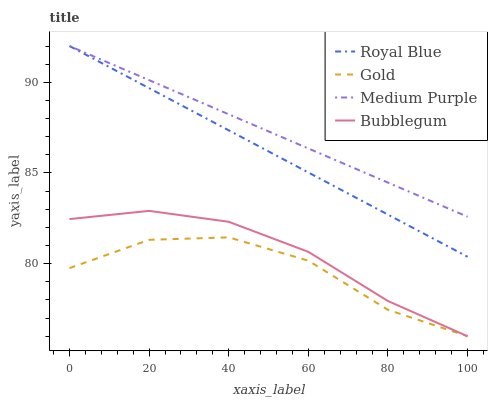Does Gold have the minimum area under the curve?
Answer yes or no. Yes. Does Medium Purple have the maximum area under the curve?
Answer yes or no. Yes. Does Royal Blue have the minimum area under the curve?
Answer yes or no. No. Does Royal Blue have the maximum area under the curve?
Answer yes or no. No. Is Royal Blue the smoothest?
Answer yes or no. Yes. Is Gold the roughest?
Answer yes or no. Yes. Is Bubblegum the smoothest?
Answer yes or no. No. Is Bubblegum the roughest?
Answer yes or no. No. Does Bubblegum have the lowest value?
Answer yes or no. Yes. Does Royal Blue have the lowest value?
Answer yes or no. No. Does Royal Blue have the highest value?
Answer yes or no. Yes. Does Bubblegum have the highest value?
Answer yes or no. No. Is Bubblegum less than Medium Purple?
Answer yes or no. Yes. Is Royal Blue greater than Bubblegum?
Answer yes or no. Yes. Does Bubblegum intersect Gold?
Answer yes or no. Yes. Is Bubblegum less than Gold?
Answer yes or no. No. Is Bubblegum greater than Gold?
Answer yes or no. No. Does Bubblegum intersect Medium Purple?
Answer yes or no. No. 